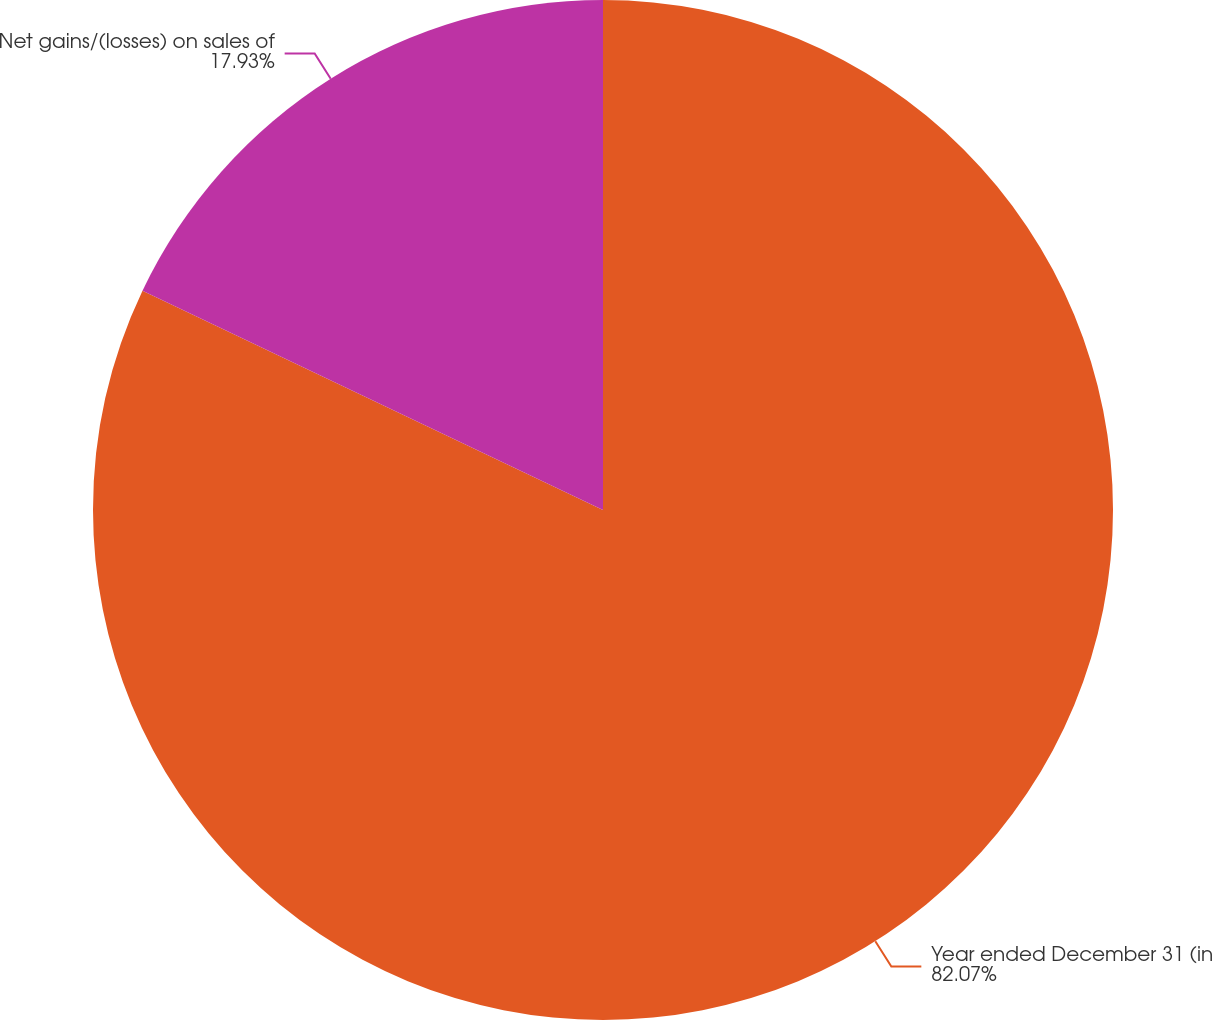<chart> <loc_0><loc_0><loc_500><loc_500><pie_chart><fcel>Year ended December 31 (in<fcel>Net gains/(losses) on sales of<nl><fcel>82.07%<fcel>17.93%<nl></chart> 